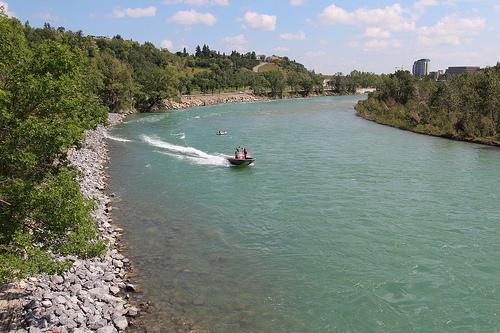How many red boats are there?
Give a very brief answer. 1. 